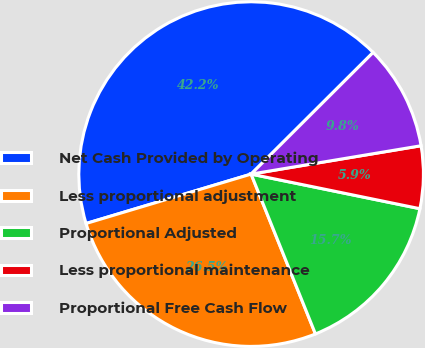Convert chart to OTSL. <chart><loc_0><loc_0><loc_500><loc_500><pie_chart><fcel>Net Cash Provided by Operating<fcel>Less proportional adjustment<fcel>Proportional Adjusted<fcel>Less proportional maintenance<fcel>Proportional Free Cash Flow<nl><fcel>42.15%<fcel>26.46%<fcel>15.69%<fcel>5.85%<fcel>9.84%<nl></chart> 